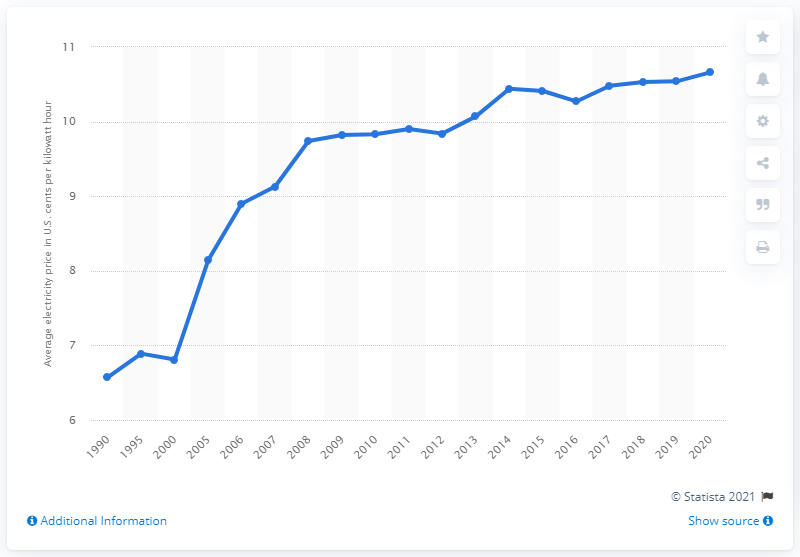Draw attention to some important aspects in this diagram. The average retail price for electricity in the United States in 2020 was 10.66 cents per kilowatt-hour. 